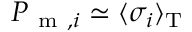<formula> <loc_0><loc_0><loc_500><loc_500>P _ { m , i } \simeq \langle \sigma _ { i } \rangle _ { T }</formula> 